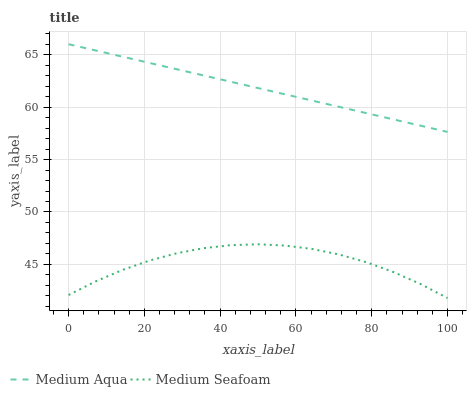Does Medium Seafoam have the minimum area under the curve?
Answer yes or no. Yes. Does Medium Aqua have the maximum area under the curve?
Answer yes or no. Yes. Does Medium Seafoam have the maximum area under the curve?
Answer yes or no. No. Is Medium Aqua the smoothest?
Answer yes or no. Yes. Is Medium Seafoam the roughest?
Answer yes or no. Yes. Is Medium Seafoam the smoothest?
Answer yes or no. No. Does Medium Seafoam have the lowest value?
Answer yes or no. Yes. Does Medium Aqua have the highest value?
Answer yes or no. Yes. Does Medium Seafoam have the highest value?
Answer yes or no. No. Is Medium Seafoam less than Medium Aqua?
Answer yes or no. Yes. Is Medium Aqua greater than Medium Seafoam?
Answer yes or no. Yes. Does Medium Seafoam intersect Medium Aqua?
Answer yes or no. No. 